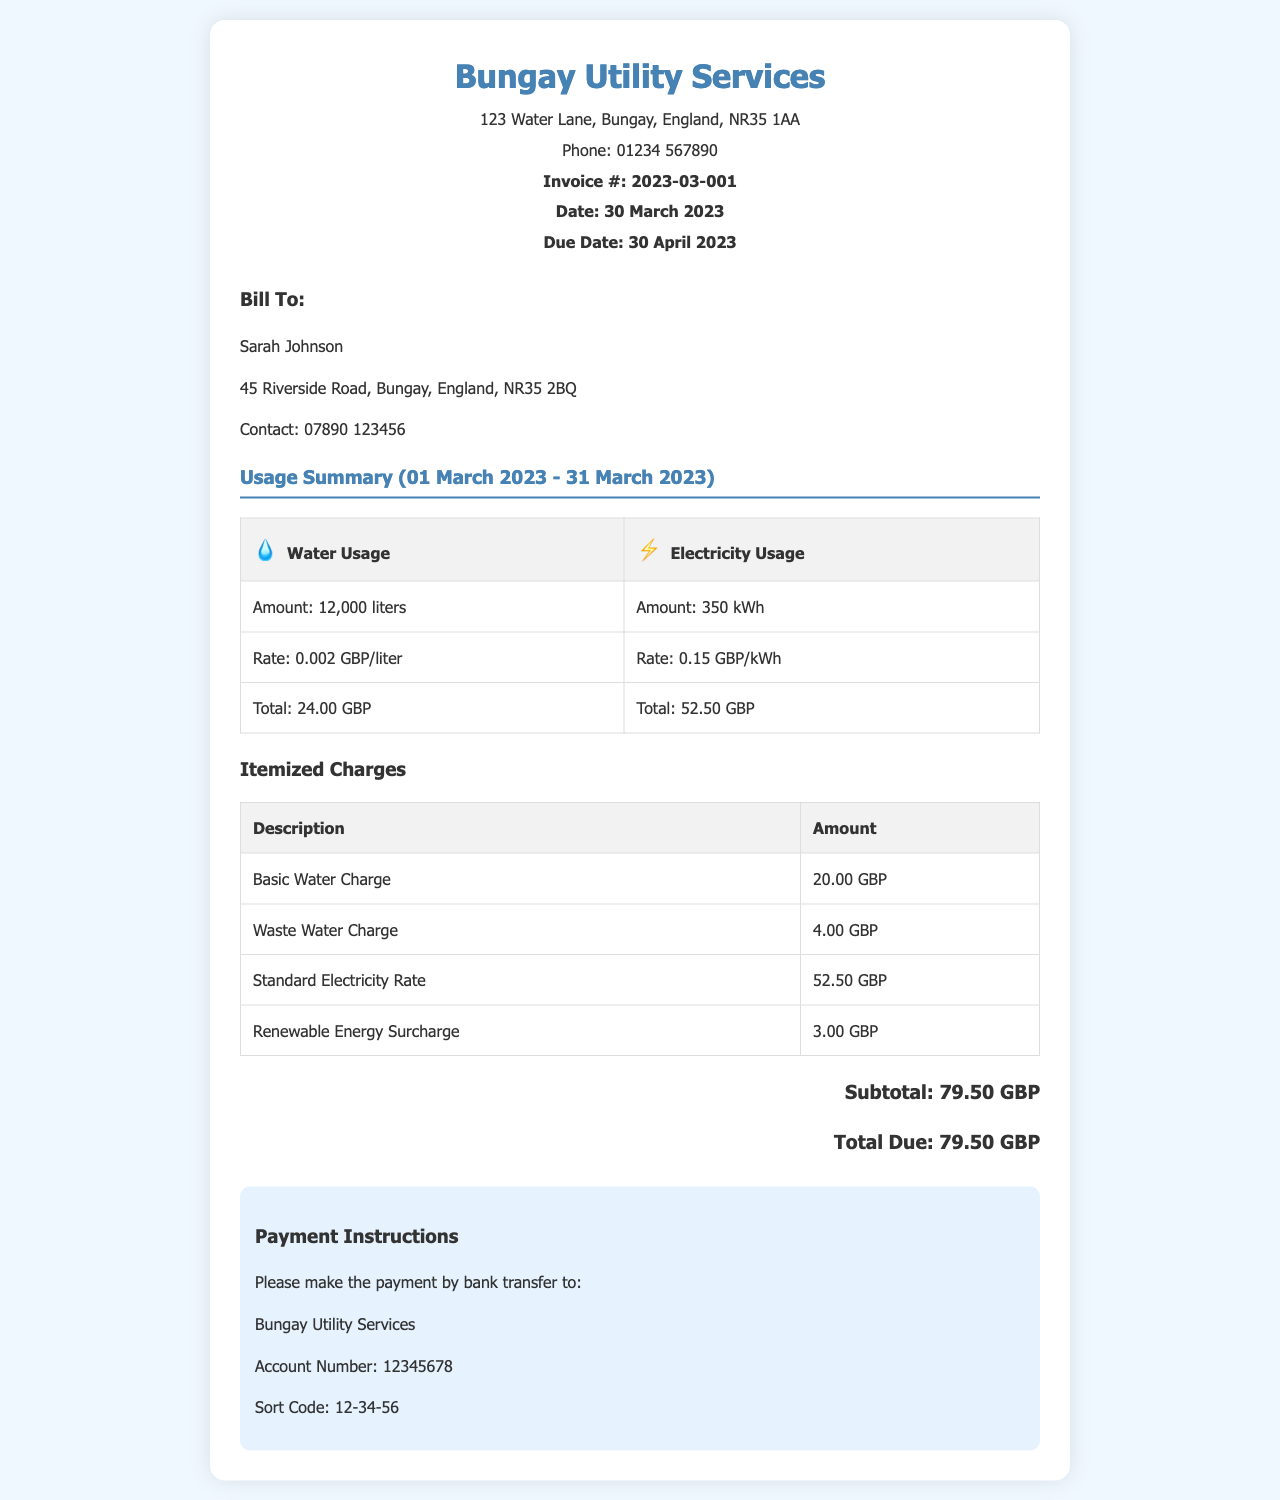What is the total due? The total due is mentioned at the end of the invoice, summarizing all charges.
Answer: 79.50 GBP Who is the invoice billed to? The bill is directed to a specific customer, whose name is located in the customer information section.
Answer: Sarah Johnson What is the water usage amount? The water usage amount can be found in the usage summary table.
Answer: 12,000 liters What is the due date for payment? The due date is clearly stated in the invoice, indicating when payment should be made.
Answer: 30 April 2023 How much is the Waste Water Charge? This charge is detailed in the itemized charges section of the invoice.
Answer: 4.00 GBP What is the rate for standard electricity? The rate for electricity is specified in the usage summary table.
Answer: 0.15 GBP/kWh What is the total cost for water? The total water cost is calculated in the usage summary and reflects the total amount owed for water services.
Answer: 24.00 GBP How many kWh were used for electricity? The total electricity usage is shown in the usage summary table.
Answer: 350 kWh What is the account number for payment? The account number for payment is provided in the payment instructions section.
Answer: 12345678 